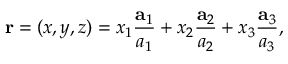<formula> <loc_0><loc_0><loc_500><loc_500>r = ( x , y , z ) = x _ { 1 } { \frac { a _ { 1 } } { a _ { 1 } } } + x _ { 2 } { \frac { a _ { 2 } } { a _ { 2 } } } + x _ { 3 } { \frac { a _ { 3 } } { a _ { 3 } } } ,</formula> 